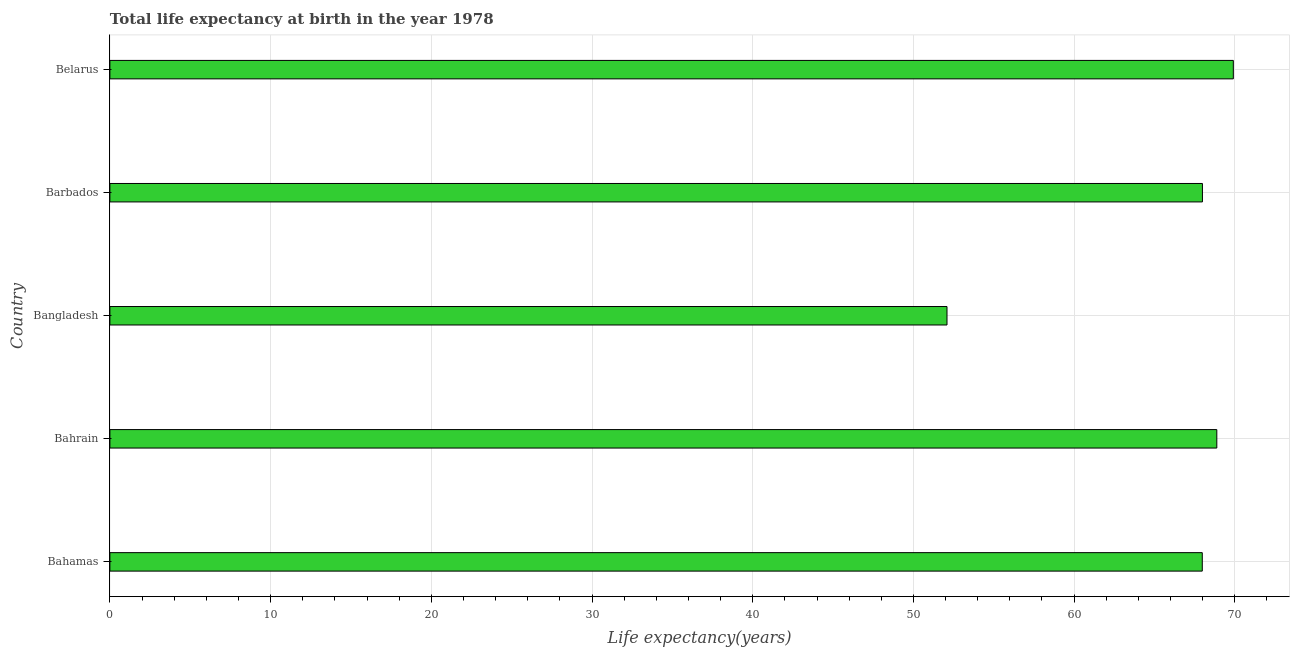What is the title of the graph?
Offer a very short reply. Total life expectancy at birth in the year 1978. What is the label or title of the X-axis?
Provide a short and direct response. Life expectancy(years). What is the label or title of the Y-axis?
Make the answer very short. Country. What is the life expectancy at birth in Bahamas?
Ensure brevity in your answer.  67.97. Across all countries, what is the maximum life expectancy at birth?
Your answer should be very brief. 69.91. Across all countries, what is the minimum life expectancy at birth?
Ensure brevity in your answer.  52.09. In which country was the life expectancy at birth maximum?
Keep it short and to the point. Belarus. In which country was the life expectancy at birth minimum?
Your answer should be very brief. Bangladesh. What is the sum of the life expectancy at birth?
Your answer should be compact. 326.83. What is the difference between the life expectancy at birth in Bahamas and Bangladesh?
Provide a short and direct response. 15.88. What is the average life expectancy at birth per country?
Provide a short and direct response. 65.37. What is the median life expectancy at birth?
Keep it short and to the point. 67.98. In how many countries, is the life expectancy at birth greater than 34 years?
Provide a succinct answer. 5. What is the ratio of the life expectancy at birth in Bahamas to that in Barbados?
Offer a terse response. 1. What is the difference between the highest and the second highest life expectancy at birth?
Offer a terse response. 1.03. Is the sum of the life expectancy at birth in Bahamas and Bangladesh greater than the maximum life expectancy at birth across all countries?
Provide a succinct answer. Yes. What is the difference between the highest and the lowest life expectancy at birth?
Your answer should be compact. 17.82. How many bars are there?
Ensure brevity in your answer.  5. Are the values on the major ticks of X-axis written in scientific E-notation?
Make the answer very short. No. What is the Life expectancy(years) in Bahamas?
Offer a terse response. 67.97. What is the Life expectancy(years) in Bahrain?
Your answer should be very brief. 68.88. What is the Life expectancy(years) of Bangladesh?
Make the answer very short. 52.09. What is the Life expectancy(years) in Barbados?
Offer a terse response. 67.98. What is the Life expectancy(years) of Belarus?
Keep it short and to the point. 69.91. What is the difference between the Life expectancy(years) in Bahamas and Bahrain?
Make the answer very short. -0.9. What is the difference between the Life expectancy(years) in Bahamas and Bangladesh?
Ensure brevity in your answer.  15.89. What is the difference between the Life expectancy(years) in Bahamas and Barbados?
Make the answer very short. -0.01. What is the difference between the Life expectancy(years) in Bahamas and Belarus?
Provide a succinct answer. -1.93. What is the difference between the Life expectancy(years) in Bahrain and Bangladesh?
Your response must be concise. 16.79. What is the difference between the Life expectancy(years) in Bahrain and Barbados?
Provide a succinct answer. 0.89. What is the difference between the Life expectancy(years) in Bahrain and Belarus?
Your response must be concise. -1.03. What is the difference between the Life expectancy(years) in Bangladesh and Barbados?
Provide a short and direct response. -15.89. What is the difference between the Life expectancy(years) in Bangladesh and Belarus?
Give a very brief answer. -17.82. What is the difference between the Life expectancy(years) in Barbados and Belarus?
Keep it short and to the point. -1.92. What is the ratio of the Life expectancy(years) in Bahamas to that in Bahrain?
Keep it short and to the point. 0.99. What is the ratio of the Life expectancy(years) in Bahamas to that in Bangladesh?
Your answer should be compact. 1.3. What is the ratio of the Life expectancy(years) in Bahrain to that in Bangladesh?
Ensure brevity in your answer.  1.32. What is the ratio of the Life expectancy(years) in Bahrain to that in Barbados?
Keep it short and to the point. 1.01. What is the ratio of the Life expectancy(years) in Bahrain to that in Belarus?
Your answer should be very brief. 0.98. What is the ratio of the Life expectancy(years) in Bangladesh to that in Barbados?
Offer a very short reply. 0.77. What is the ratio of the Life expectancy(years) in Bangladesh to that in Belarus?
Ensure brevity in your answer.  0.74. 